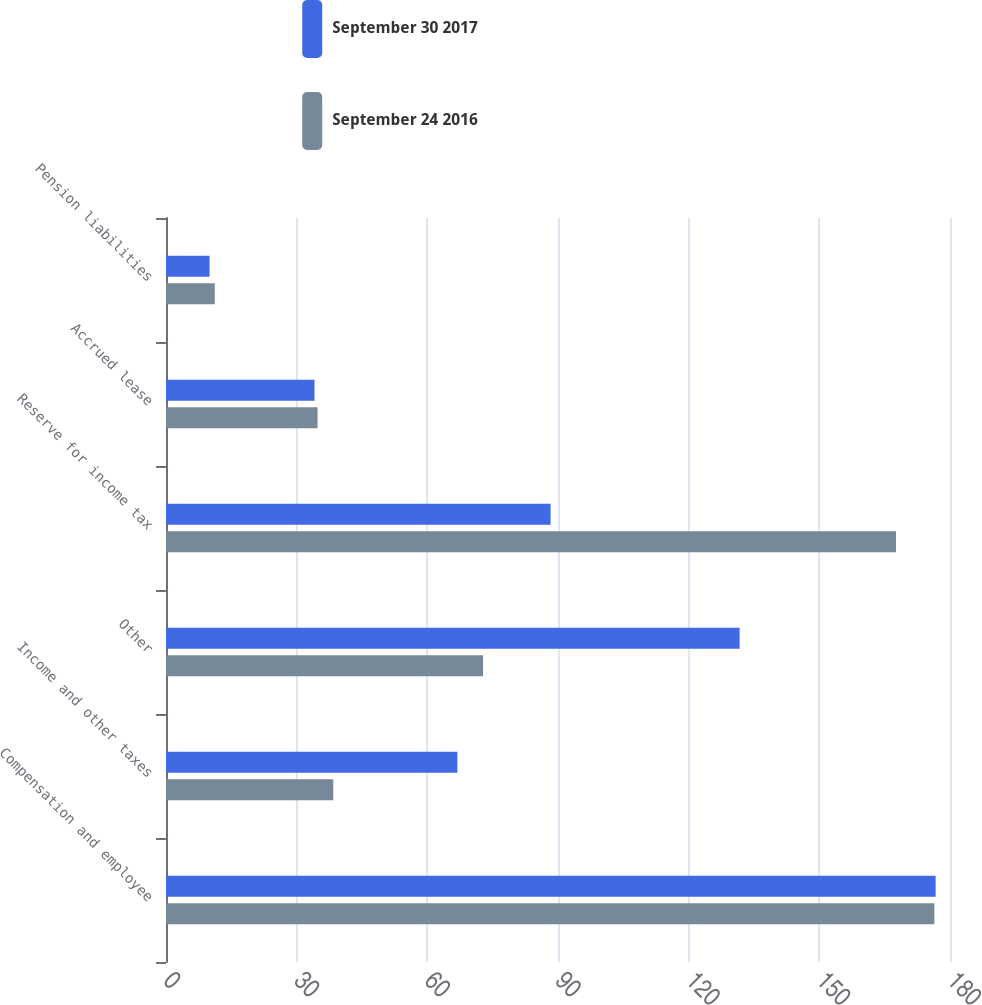Convert chart to OTSL. <chart><loc_0><loc_0><loc_500><loc_500><stacked_bar_chart><ecel><fcel>Compensation and employee<fcel>Income and other taxes<fcel>Other<fcel>Reserve for income tax<fcel>Accrued lease<fcel>Pension liabilities<nl><fcel>September 30 2017<fcel>176.7<fcel>66.9<fcel>131.7<fcel>88.3<fcel>34.1<fcel>10<nl><fcel>September 24 2016<fcel>176.4<fcel>38.4<fcel>72.8<fcel>167.6<fcel>34.8<fcel>11.2<nl></chart> 